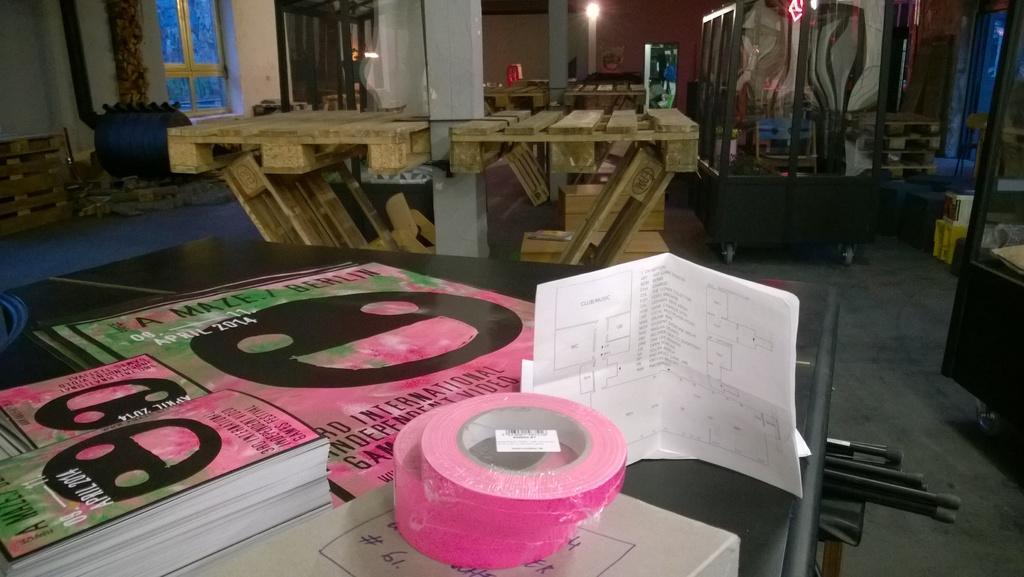Can you describe this image briefly? In this picture we can see a table in the front, there are some books, papers and tapes present on this table, we can see wooden things and pillars in the middle, on the left side there is a window, on the right side there is a glass, in the background we can see a light. 